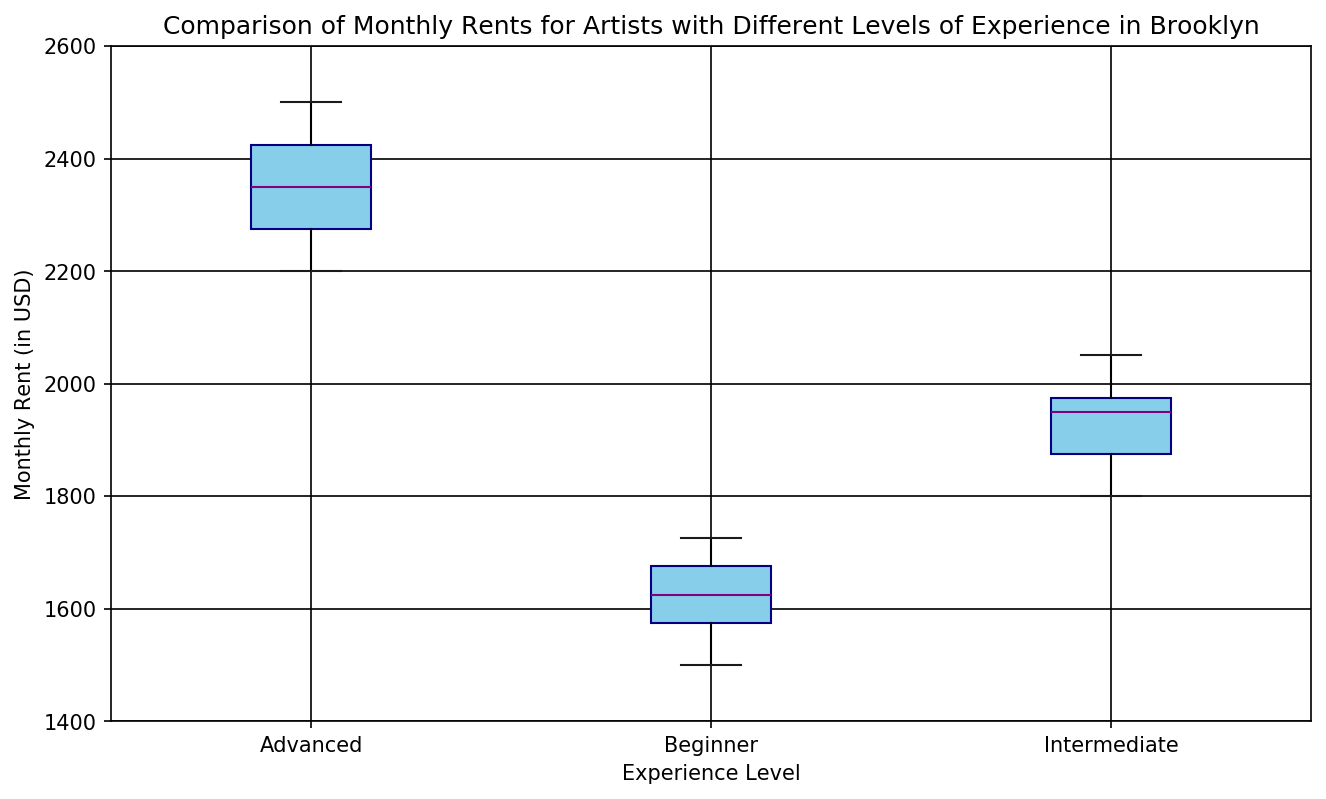What is the median monthly rent for beginner artists? Locate the "Beginner" box in the boxplot and identify the line inside the box which represents the median.
Answer: 1625 Which experience level has the highest median rent? Compare the medians (the lines inside the boxes) for all experience levels: "Beginner", "Intermediate", and "Advanced". The box with the highest line inside it corresponds to the highest median rent.
Answer: Advanced What is the interquartile range (IQR) of the monthly rent for intermediate artists? The IQR is the range between the first quartile (bottom of the box) and the third quartile (top of the box) for the "Intermediate" group. Subtract the first quartile value from the third quartile value to find the IQR.
Answer: 200 How does the spread of rents for advanced artists compare to that for beginner artists? Look at the height of the boxes for both "Advanced" and "Beginner" groups to compare the range between their first and third quartiles. A taller box indicates a larger spread.
Answer: Advanced has a larger spread Which group shows the widest range in monthly rents? Examine the difference between the smallest and largest values (whiskers of the box) for each experience level group. The group with the largest range has the widest spread in monthly rents.
Answer: Advanced Are there any outliers in the monthly rents for intermediate artists? Look for any points outside the whiskers of the "Intermediate" box. These points represent outliers.
Answer: No What is the minimum monthly rent for beginners? Identify the lowest point on the beginner boxplot, which represents the minimum monthly rent.
Answer: 1500 Which experience level has the most consistent monthly rents? Find the box with the smallest height, indicating the narrowest range between the first and third quartiles. This will be the group with the most consistent rents.
Answer: Beginner What is the difference between the median rents of intermediate and advanced artists? Identify and subtract the median value of "Intermediate" artists from that of "Advanced" artists.
Answer: 450 How does the monthly rent distribution for beginner artists compare visually to that of intermediate artists? Examine the lengths of the boxes and whiskers for both "Beginner" and "Intermediate" groups. Look at the median lines and the spread to compare their distributions.
Answer: Beginners have a lower median and a smaller spread 